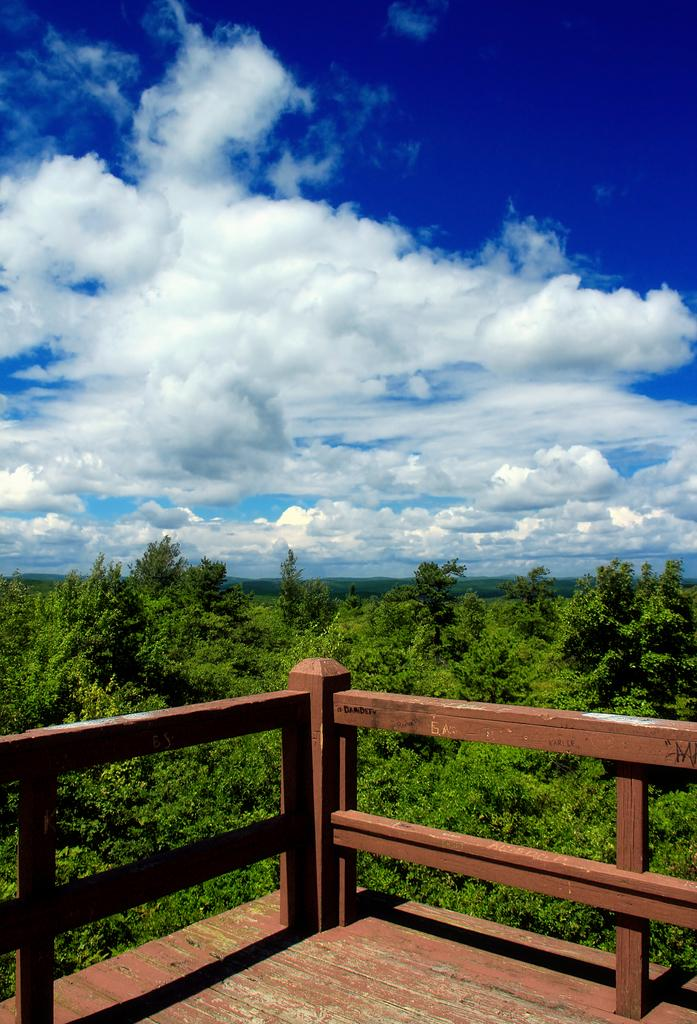What is the main structure in the image? There is a platform in the image. What is in front of the platform? There is railing in front of the platform. What type of vegetation is present in the image? There are multiple trees in the middle of the image. What can be seen in the distance in the image? The sky is visible in the background of the image. How many ducks are sitting on the wire in the image? There is no wire or ducks present in the image. 